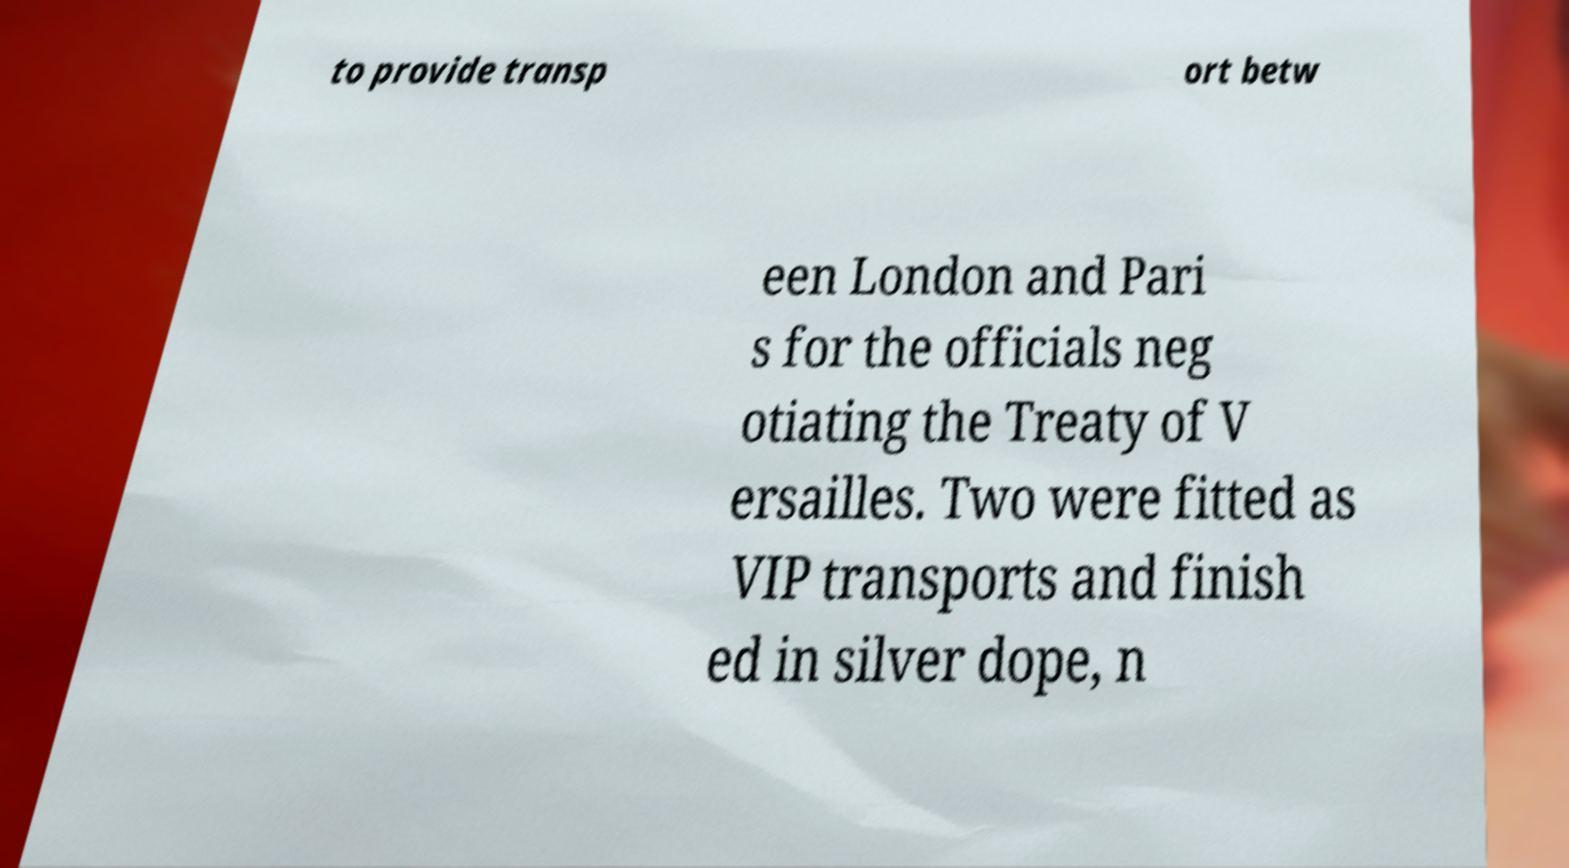There's text embedded in this image that I need extracted. Can you transcribe it verbatim? to provide transp ort betw een London and Pari s for the officials neg otiating the Treaty of V ersailles. Two were fitted as VIP transports and finish ed in silver dope, n 